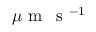Convert formula to latex. <formula><loc_0><loc_0><loc_500><loc_500>\mu m \, s ^ { - 1 }</formula> 